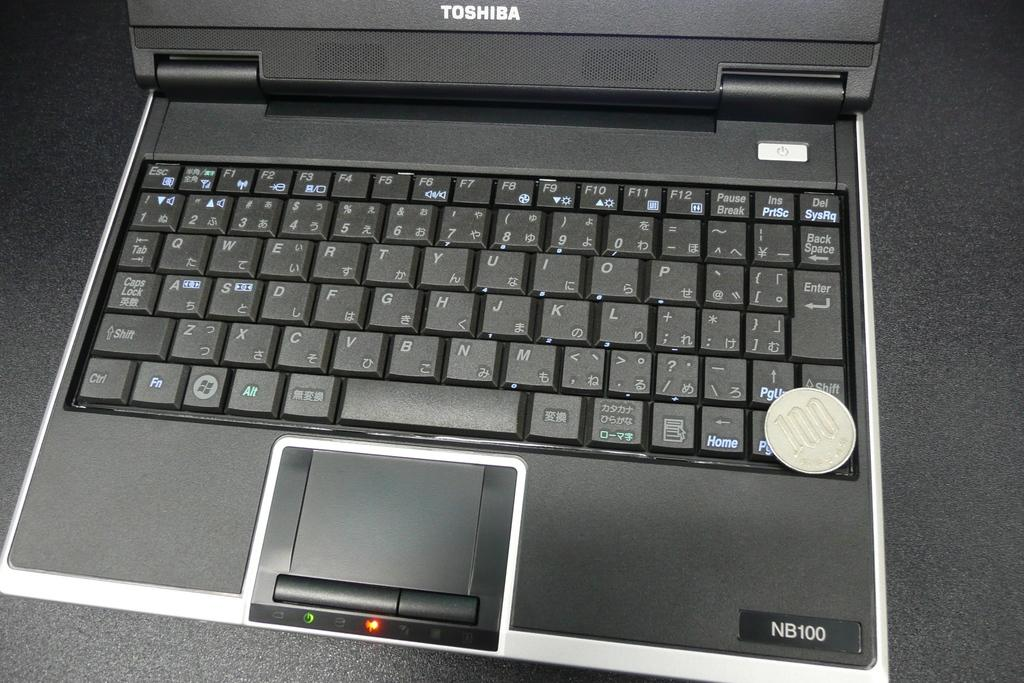Provide a one-sentence caption for the provided image. a computer that says toshiba as the brand name on it. 